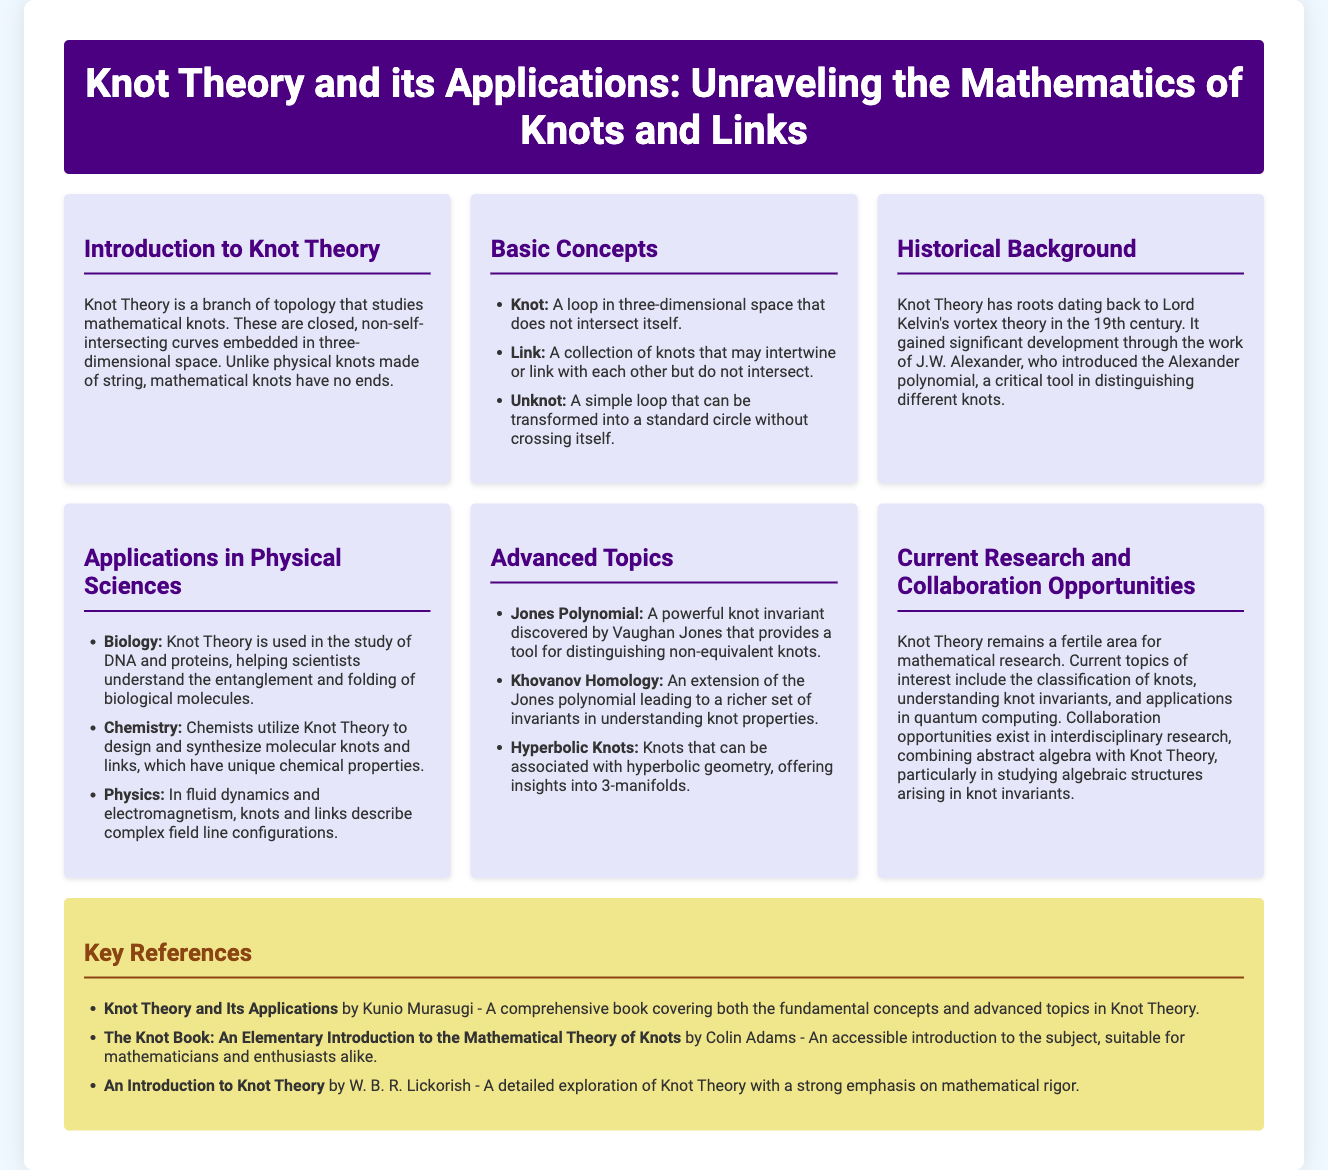What is the main focus of Knot Theory? Knot Theory studies mathematical knots, which are closed, non-self-intersecting curves in three-dimensional space.
Answer: mathematical knots What is a link? A link is a collection of knots that may intertwine or link with each other but do not intersect.
Answer: collection of knots Who introduced the Alexander polynomial? J.W. Alexander introduced the Alexander polynomial, a critical tool in distinguishing different knots.
Answer: J.W. Alexander What is one application of Knot Theory in biology? Knot Theory is used in the study of DNA and proteins, helping scientists understand the entanglement and folding of biological molecules.
Answer: DNA and proteins Which polynomial provides a tool for distinguishing non-equivalent knots? The Jones Polynomial is a powerful knot invariant discovered by Vaughan Jones that distinguishes non-equivalent knots.
Answer: Jones Polynomial What advanced topic leads to a richer set of invariants in understanding knot properties? Khovanov Homology is an extension of the Jones polynomial leading to a richer set of invariants in understanding knot properties.
Answer: Khovanov Homology What interdisciplinary area does current research in Knot Theory offer collaboration opportunities? Current research in Knot Theory offers collaboration opportunities in combining abstract algebra with Knot Theory, particularly in studying algebraic structures.
Answer: abstract algebra What is the title of a comprehensive book on Knot Theory mentioned as a reference? "Knot Theory and Its Applications" by Kunio Murasugi is a comprehensive book covering fundamental concepts and advanced topics in Knot Theory.
Answer: Knot Theory and Its Applications 